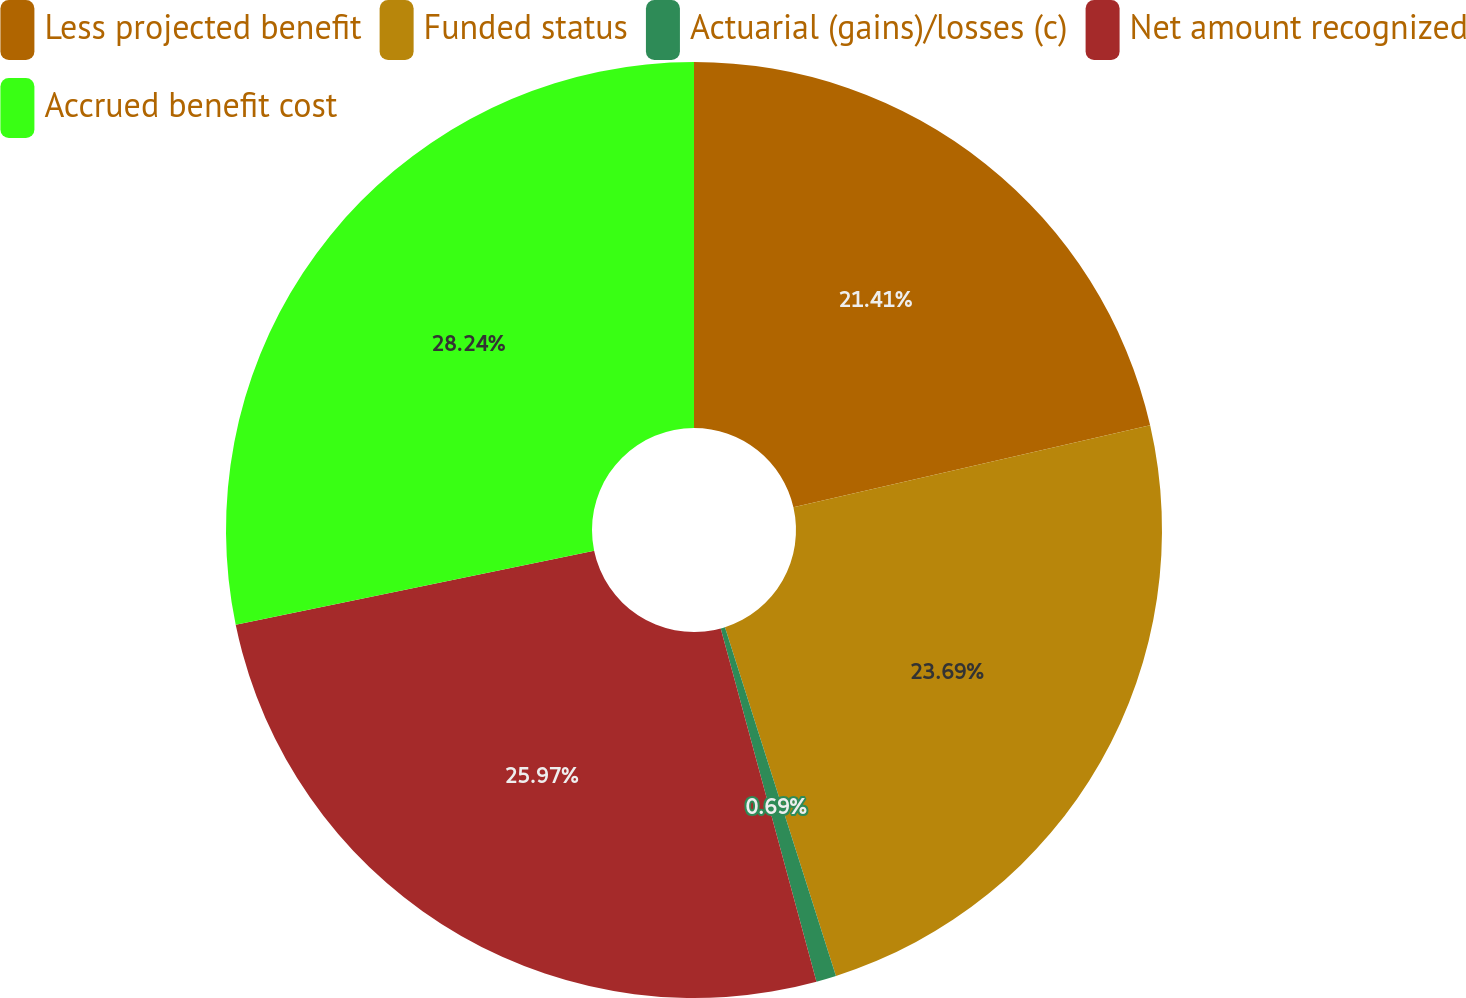Convert chart to OTSL. <chart><loc_0><loc_0><loc_500><loc_500><pie_chart><fcel>Less projected benefit<fcel>Funded status<fcel>Actuarial (gains)/losses (c)<fcel>Net amount recognized<fcel>Accrued benefit cost<nl><fcel>21.41%<fcel>23.69%<fcel>0.69%<fcel>25.97%<fcel>28.25%<nl></chart> 